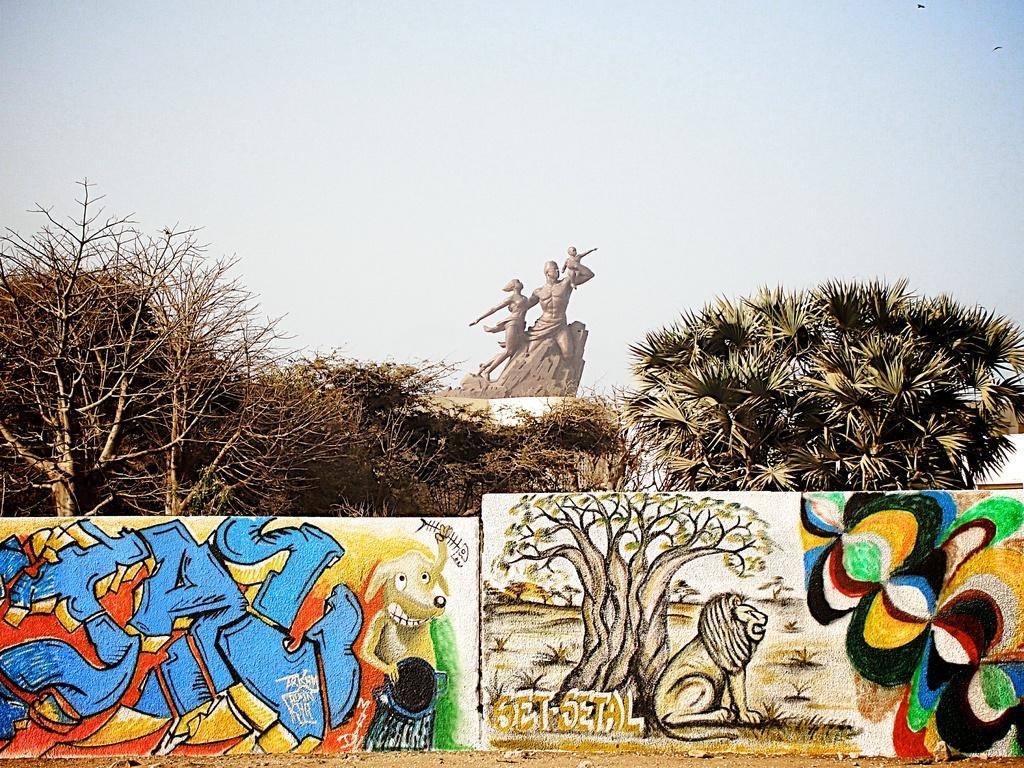Please provide a concise description of this image. In this image we can see a sculpture, there are some trees and the graffiti on the walls, in the background we can see the sky. 